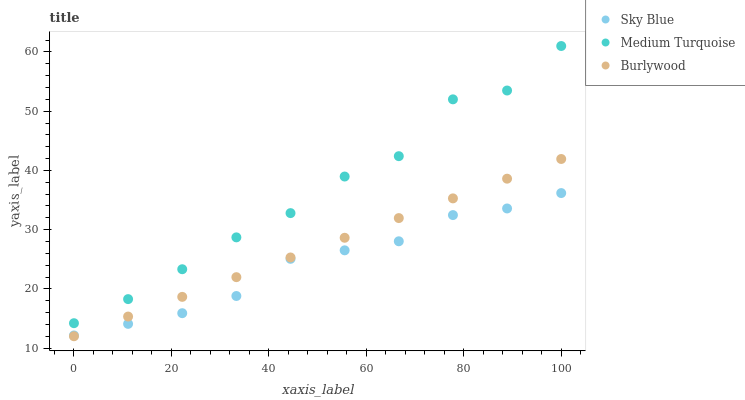Does Sky Blue have the minimum area under the curve?
Answer yes or no. Yes. Does Medium Turquoise have the maximum area under the curve?
Answer yes or no. Yes. Does Medium Turquoise have the minimum area under the curve?
Answer yes or no. No. Does Sky Blue have the maximum area under the curve?
Answer yes or no. No. Is Burlywood the smoothest?
Answer yes or no. Yes. Is Medium Turquoise the roughest?
Answer yes or no. Yes. Is Sky Blue the smoothest?
Answer yes or no. No. Is Sky Blue the roughest?
Answer yes or no. No. Does Burlywood have the lowest value?
Answer yes or no. Yes. Does Sky Blue have the lowest value?
Answer yes or no. No. Does Medium Turquoise have the highest value?
Answer yes or no. Yes. Does Sky Blue have the highest value?
Answer yes or no. No. Is Burlywood less than Medium Turquoise?
Answer yes or no. Yes. Is Medium Turquoise greater than Sky Blue?
Answer yes or no. Yes. Does Burlywood intersect Sky Blue?
Answer yes or no. Yes. Is Burlywood less than Sky Blue?
Answer yes or no. No. Is Burlywood greater than Sky Blue?
Answer yes or no. No. Does Burlywood intersect Medium Turquoise?
Answer yes or no. No. 